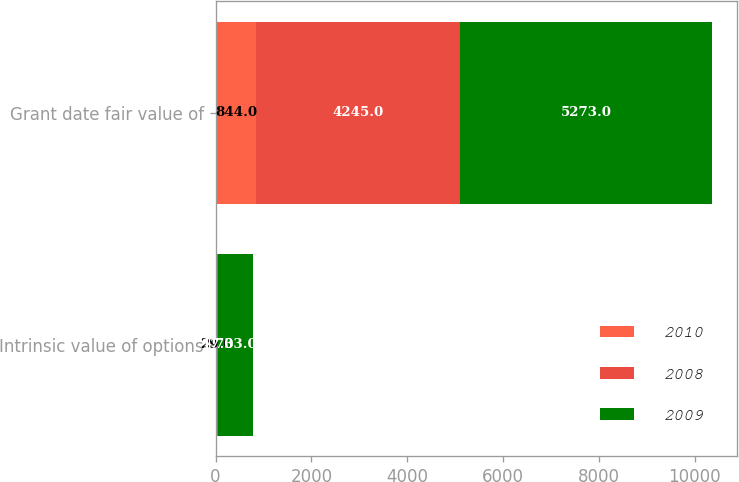<chart> <loc_0><loc_0><loc_500><loc_500><stacked_bar_chart><ecel><fcel>Intrinsic value of options<fcel>Grant date fair value of<nl><fcel>2010<fcel>29<fcel>844<nl><fcel>2008<fcel>17<fcel>4245<nl><fcel>2009<fcel>733<fcel>5273<nl></chart> 